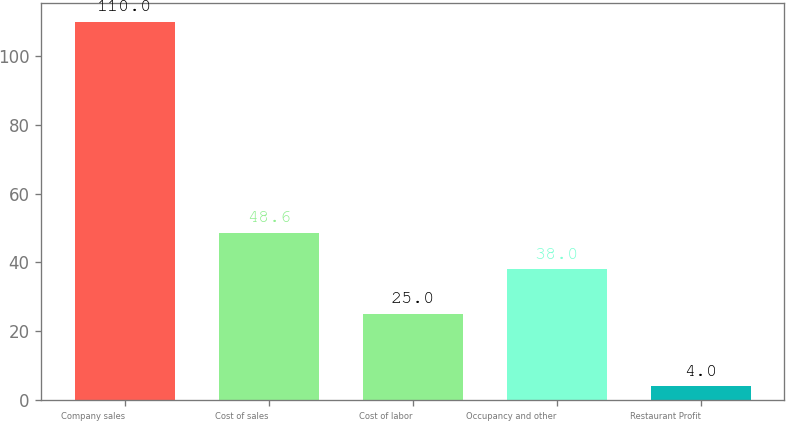Convert chart to OTSL. <chart><loc_0><loc_0><loc_500><loc_500><bar_chart><fcel>Company sales<fcel>Cost of sales<fcel>Cost of labor<fcel>Occupancy and other<fcel>Restaurant Profit<nl><fcel>110<fcel>48.6<fcel>25<fcel>38<fcel>4<nl></chart> 